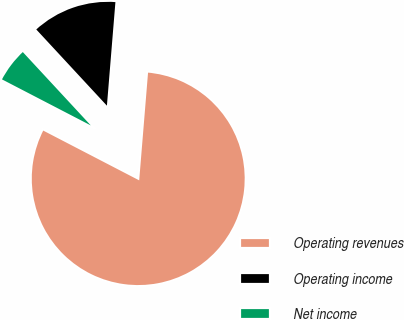Convert chart. <chart><loc_0><loc_0><loc_500><loc_500><pie_chart><fcel>Operating revenues<fcel>Operating income<fcel>Net income<nl><fcel>81.31%<fcel>13.2%<fcel>5.49%<nl></chart> 